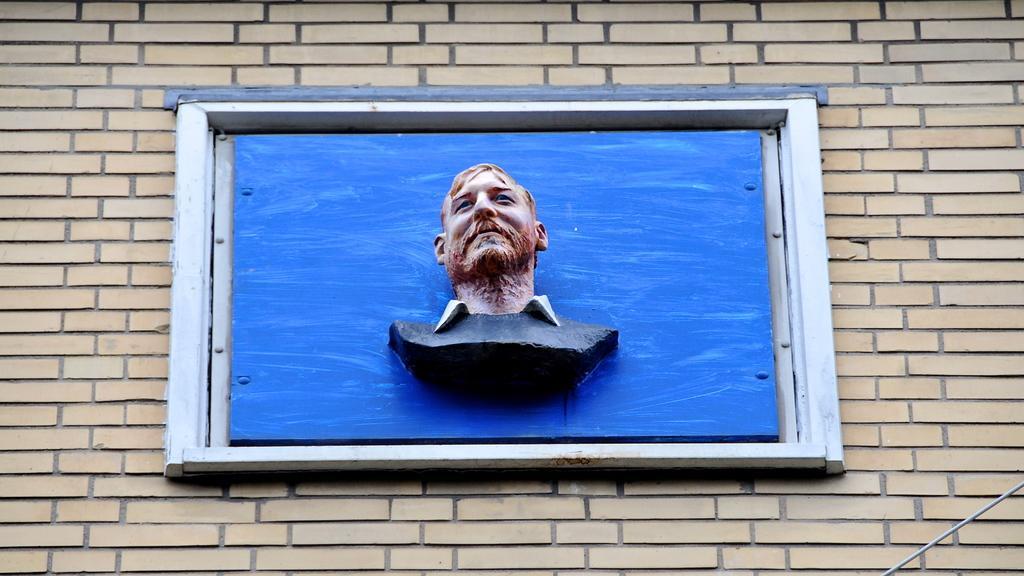Could you give a brief overview of what you see in this image? In the image there is a man sculpture on a window over the wall. 